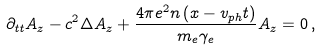Convert formula to latex. <formula><loc_0><loc_0><loc_500><loc_500>\partial _ { t t } A _ { z } - c ^ { 2 } \Delta A _ { z } + \frac { 4 \pi e ^ { 2 } n \left ( x - v _ { p h } t \right ) } { m _ { e } \gamma _ { e } } A _ { z } = 0 \, ,</formula> 